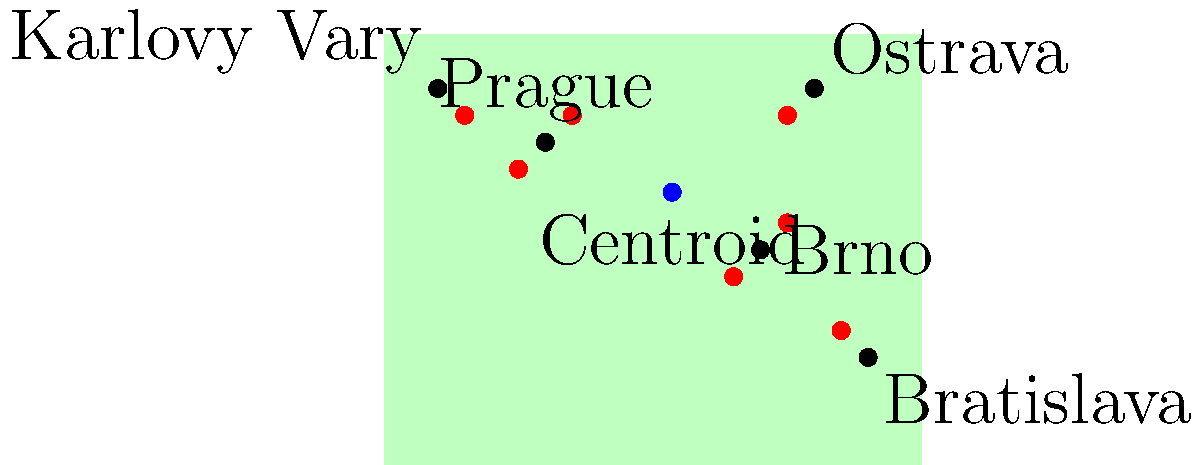Based on the map of former Czechoslovakia showing locations of Czech New Wave film productions (red dots), what spatial pattern can be observed, and how does it relate to the cultural significance of these filming locations? To answer this question, we need to analyze the spatial distribution of the film locations and their relationship to major cities:

1. Observe the distribution: The red dots representing film locations are not evenly spread across the map. There is a clear concentration around certain areas.

2. Identify clusters: We can see that there are two main clusters of film locations:
   a) A larger cluster around Prague in the western part of the country
   b) A smaller cluster near Brno in the southeastern part

3. Relation to cities: 
   - The largest cluster is centered around Prague, the capital and cultural heart of Czechoslovakia
   - There are also film locations near other major cities like Brno and Bratislava

4. Cultural significance:
   - Prague was the center of the Czech New Wave movement, which explains the concentration of locations around it
   - The presence of locations near other cities suggests that filmmakers also sought to capture the diversity of the country

5. Spatial pattern:
   - The distribution follows a "core-periphery" pattern, with Prague as the core and other locations as the periphery
   - This pattern reflects the centralized nature of the film industry and cultural production in Czechoslovakia during the New Wave era

6. Centroid analysis:
   - The blue dot represents the centroid (average location) of all film locations
   - Its position being closer to Prague further emphasizes the city's dominance in the spatial distribution

In conclusion, the spatial pattern shows a centralized distribution focused on Prague, with secondary clusters near other major cities, reflecting the cultural and logistical importance of urban centers in the Czech New Wave movement.
Answer: Core-periphery pattern centered on Prague 